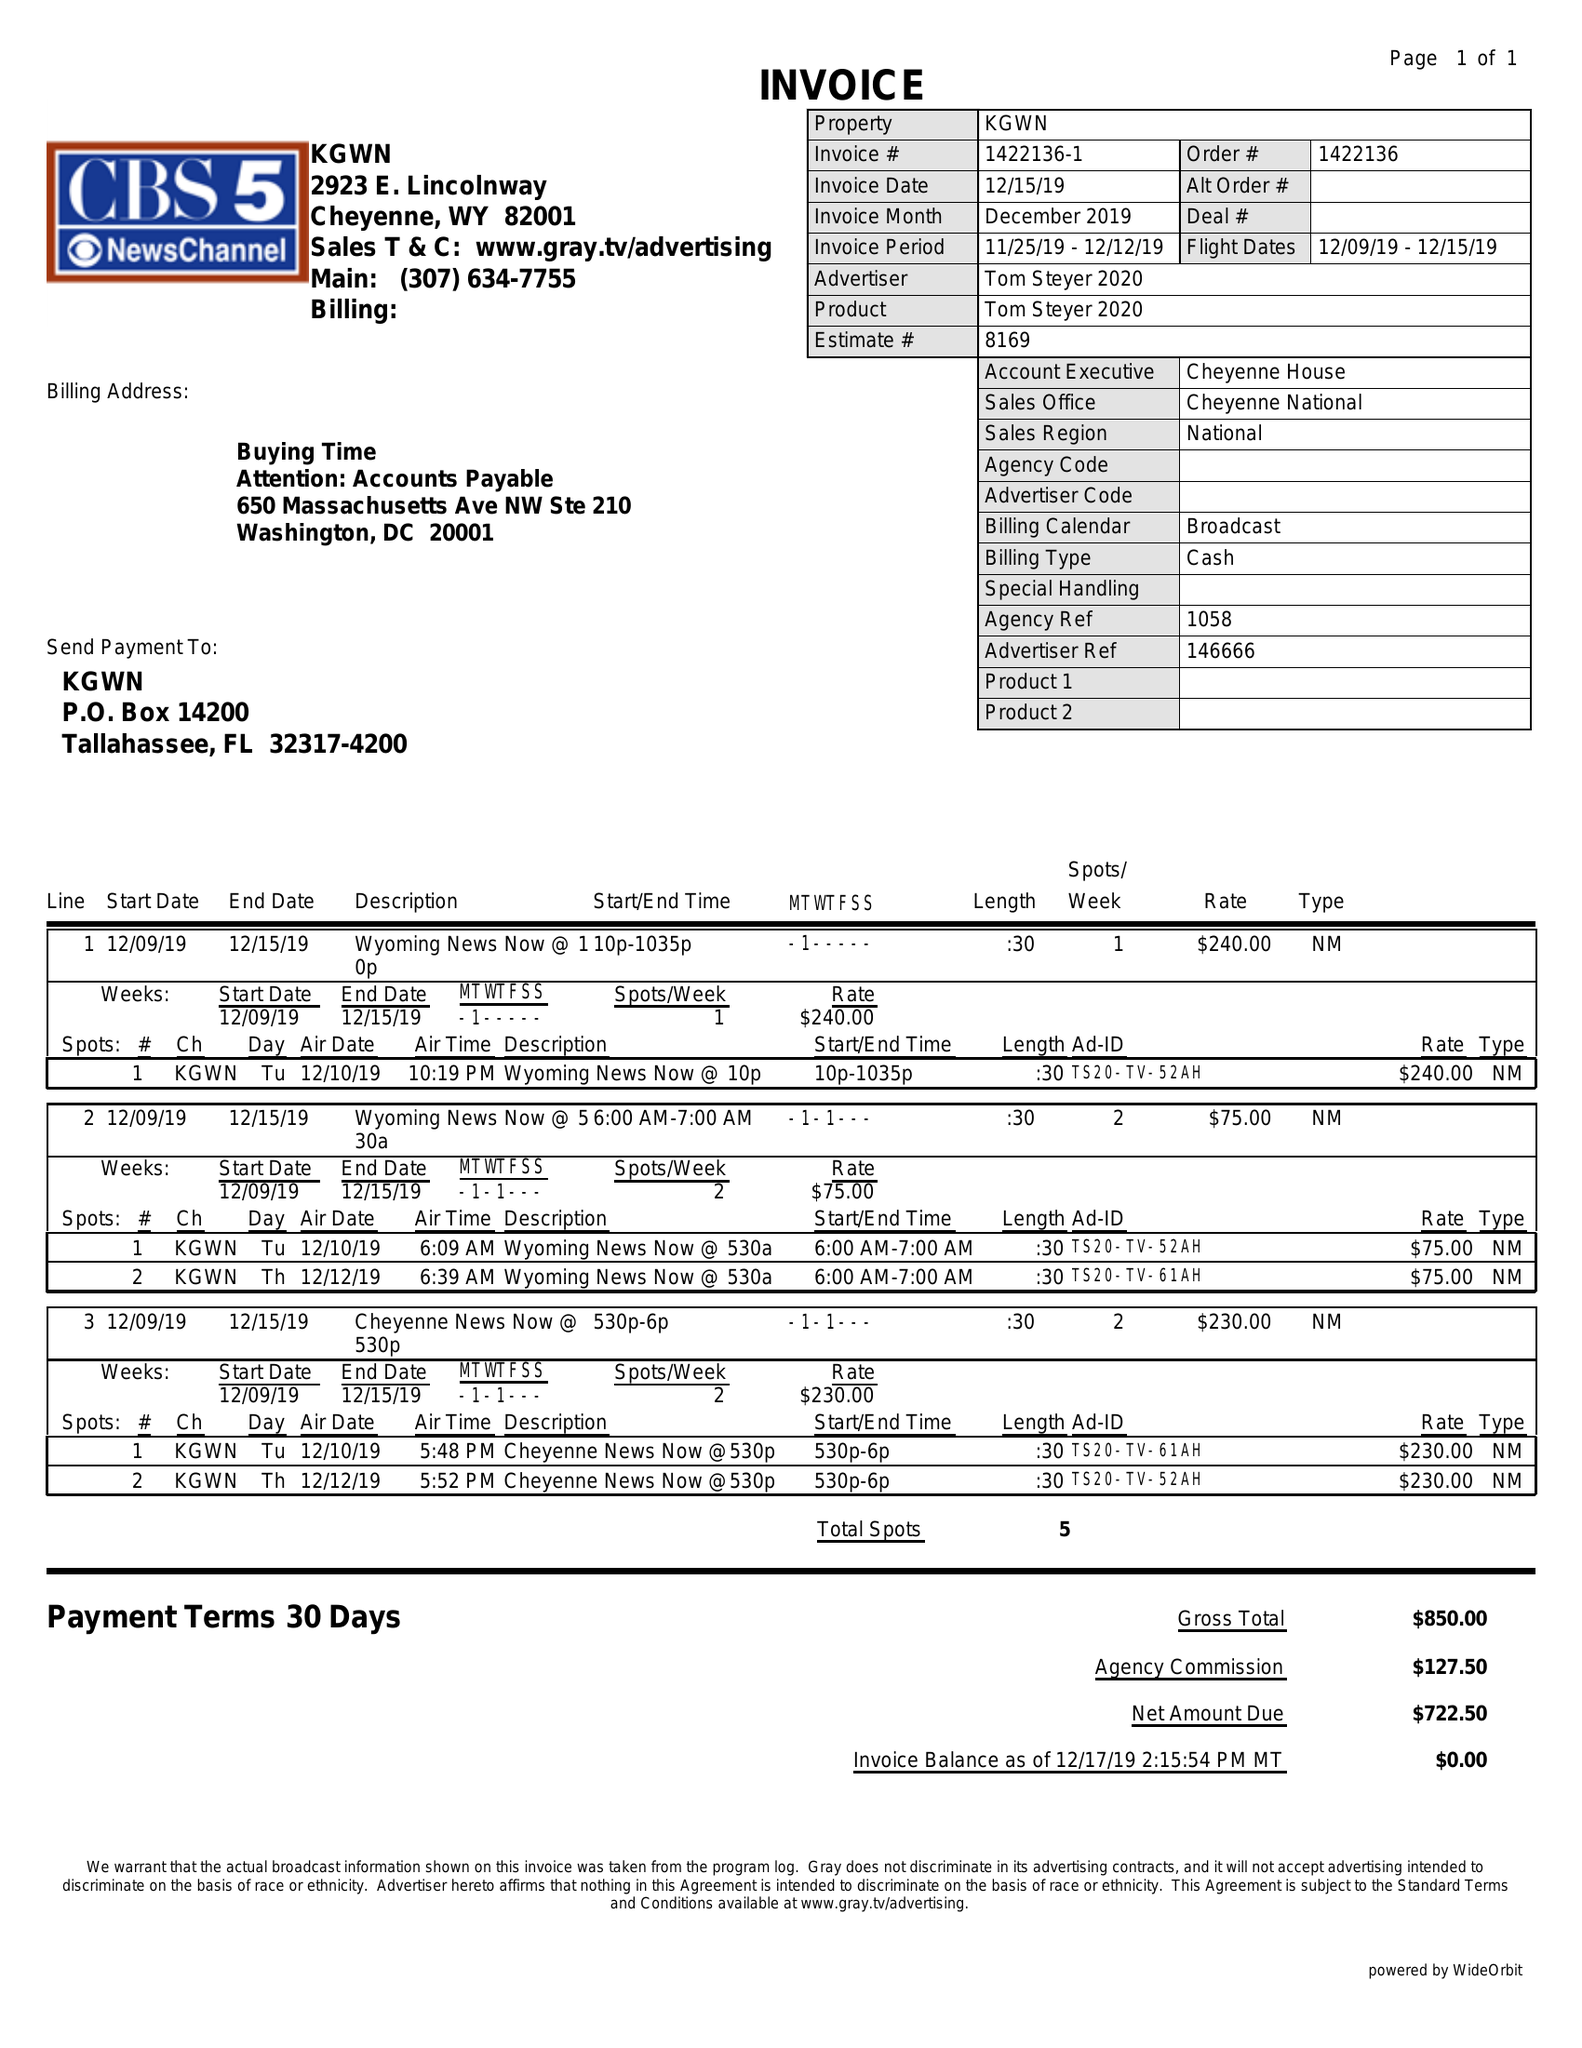What is the value for the gross_amount?
Answer the question using a single word or phrase. 850.00 